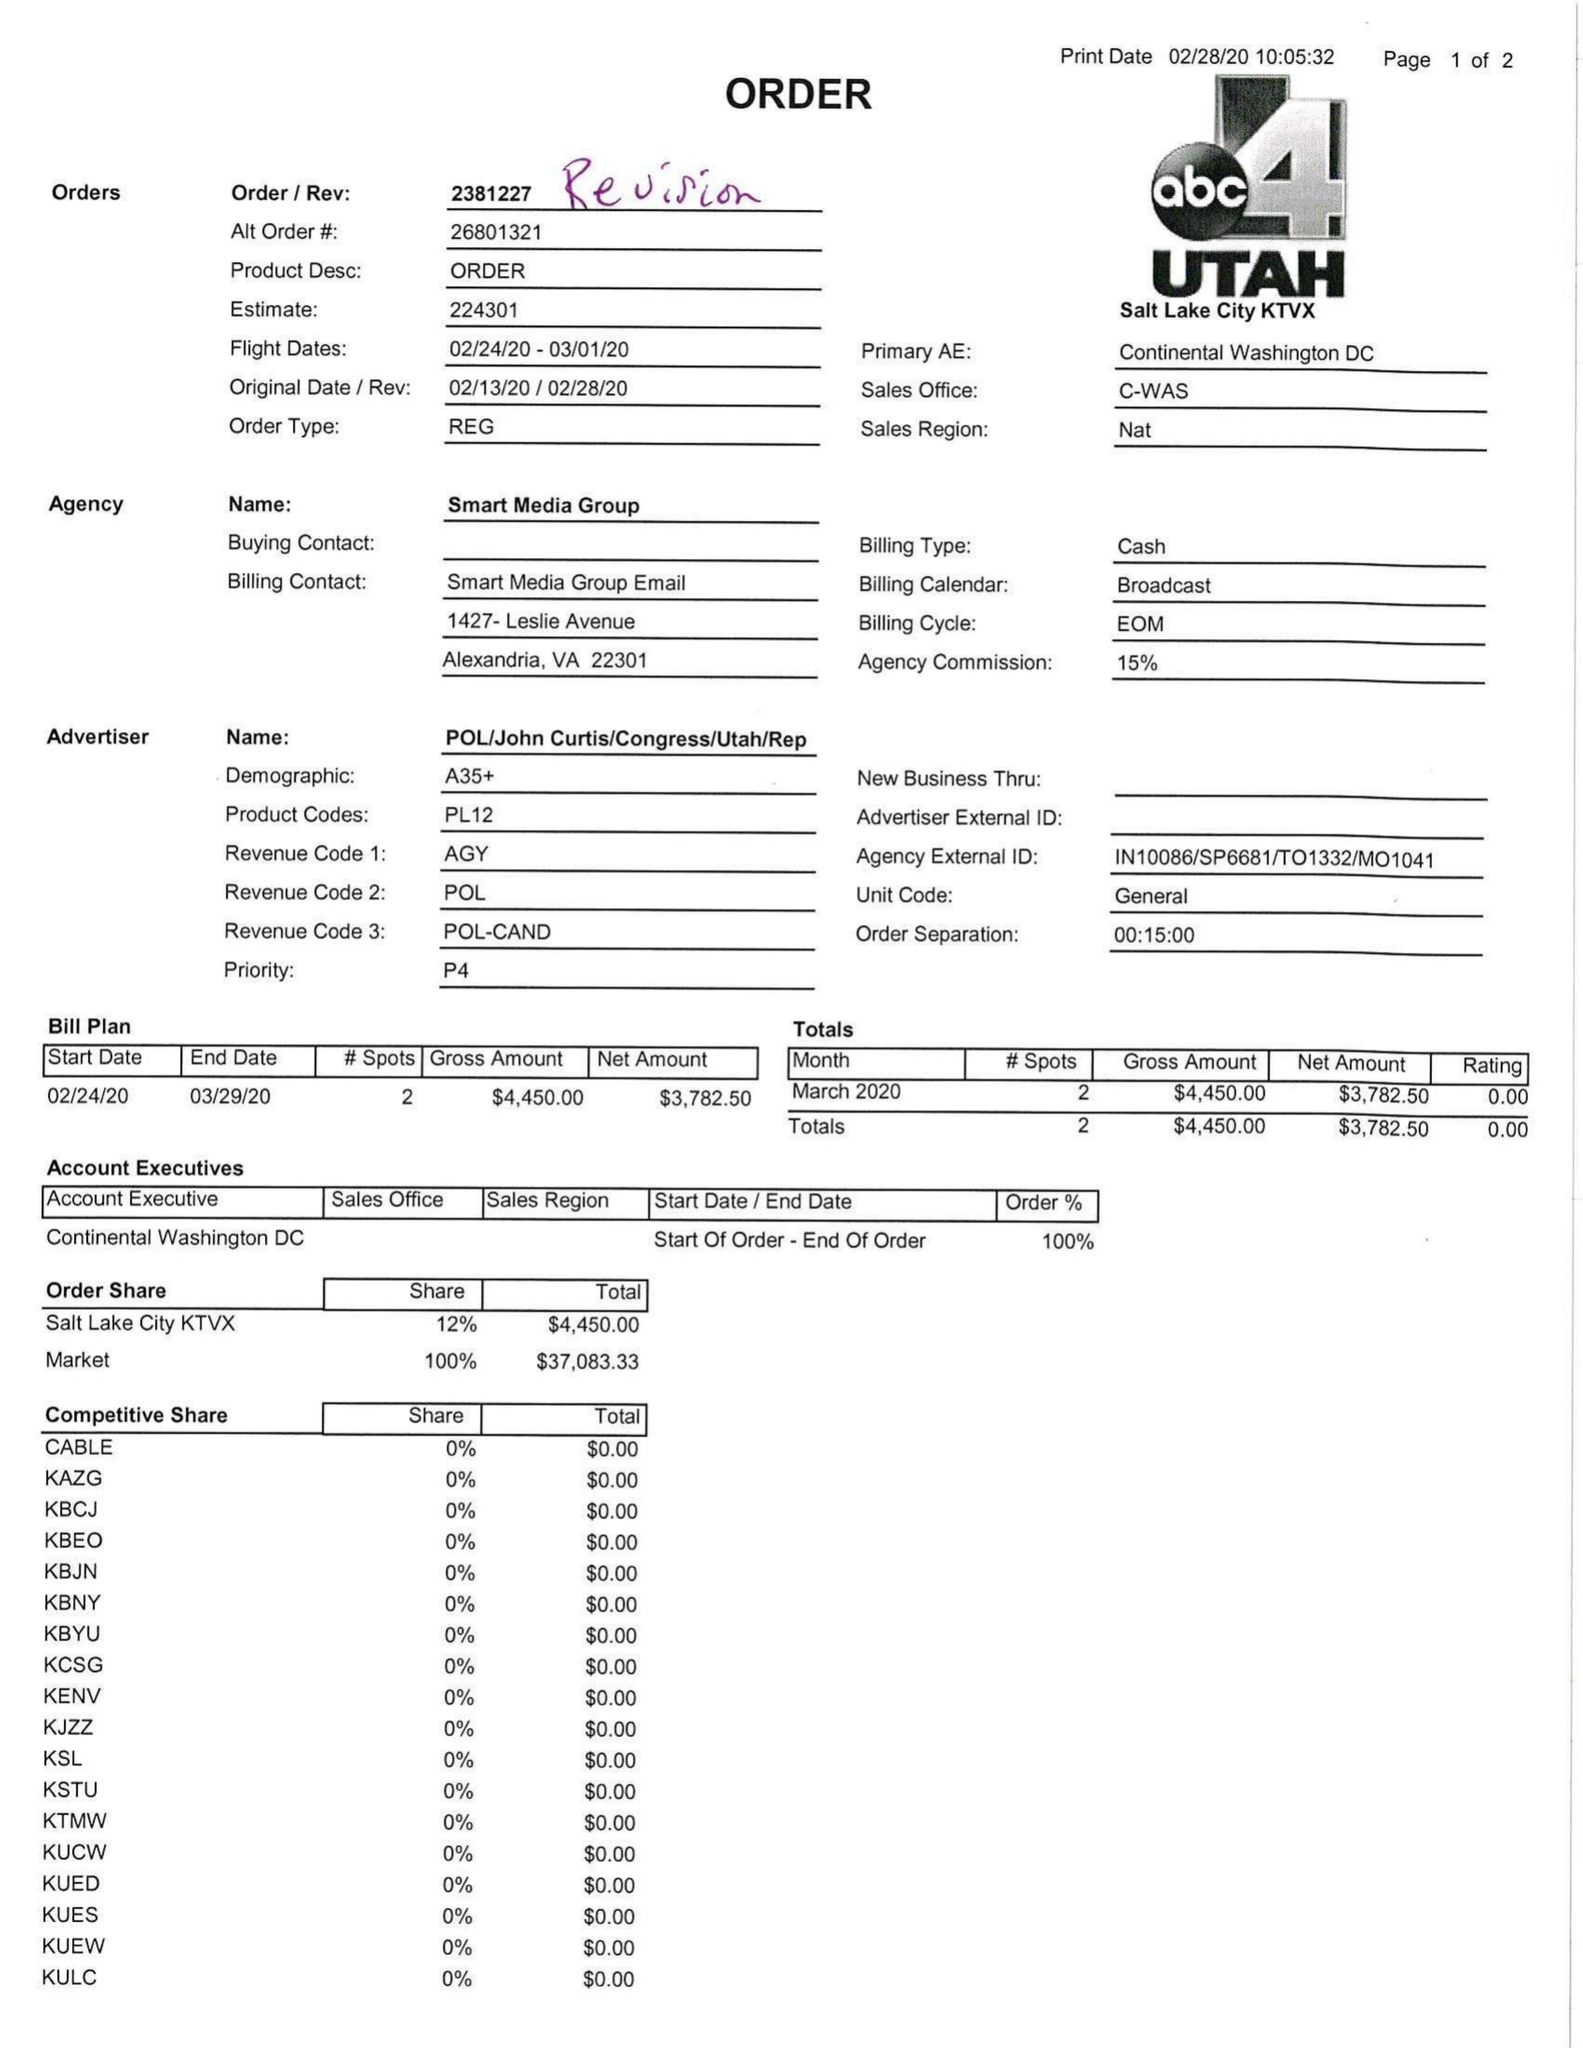What is the value for the flight_to?
Answer the question using a single word or phrase. 03/01/20 